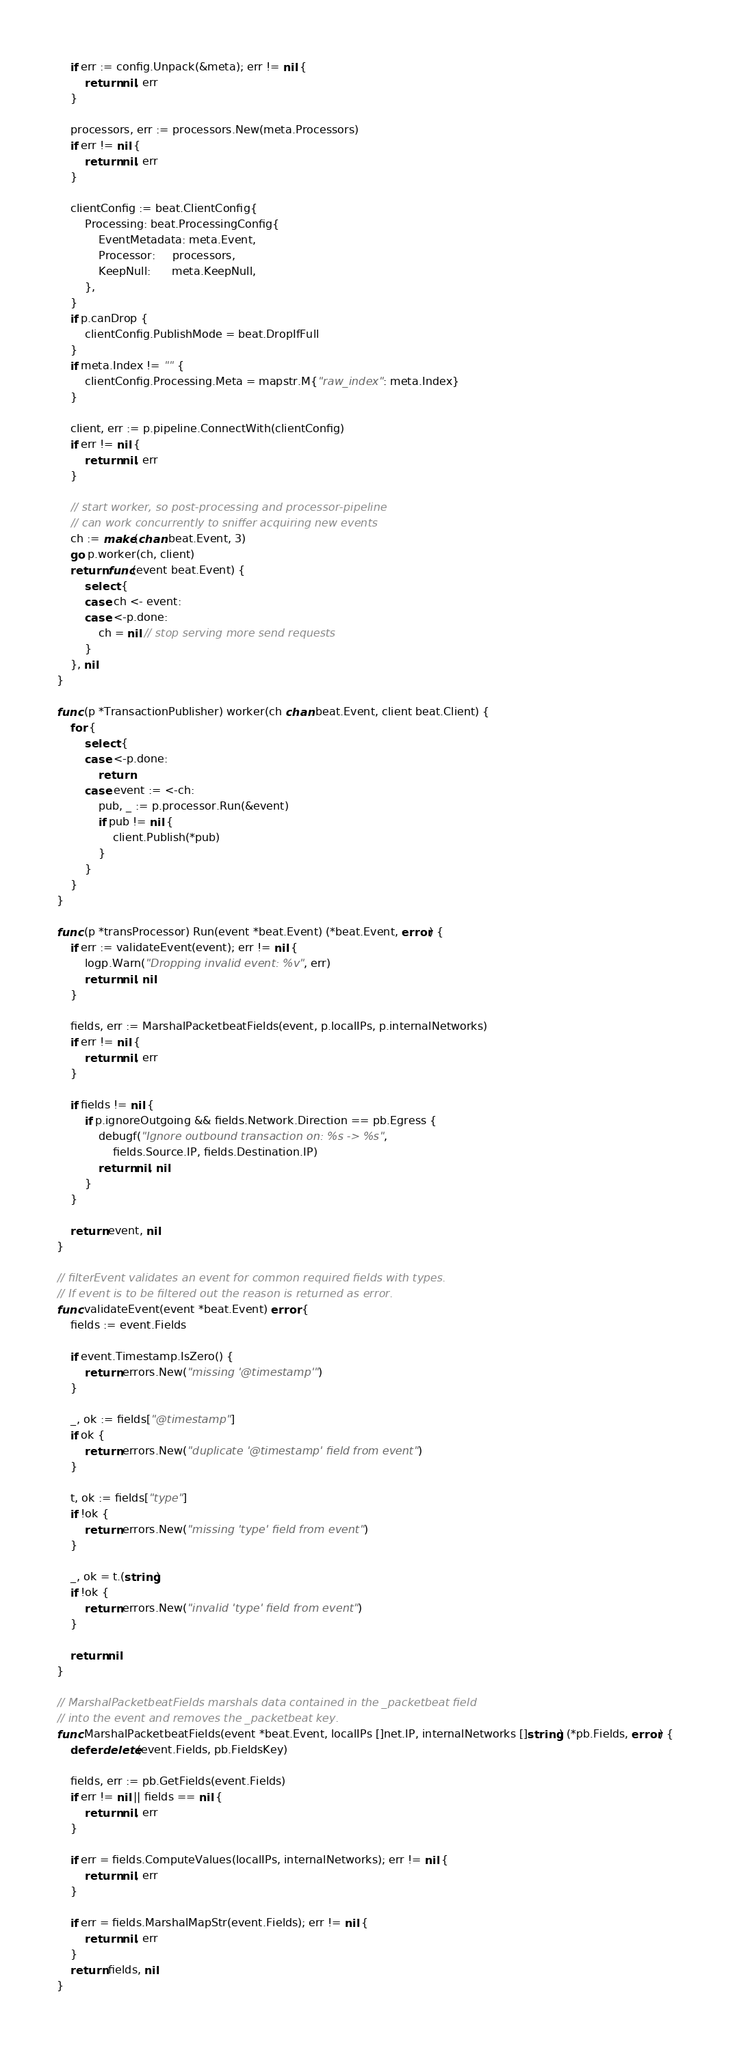Convert code to text. <code><loc_0><loc_0><loc_500><loc_500><_Go_>	if err := config.Unpack(&meta); err != nil {
		return nil, err
	}

	processors, err := processors.New(meta.Processors)
	if err != nil {
		return nil, err
	}

	clientConfig := beat.ClientConfig{
		Processing: beat.ProcessingConfig{
			EventMetadata: meta.Event,
			Processor:     processors,
			KeepNull:      meta.KeepNull,
		},
	}
	if p.canDrop {
		clientConfig.PublishMode = beat.DropIfFull
	}
	if meta.Index != "" {
		clientConfig.Processing.Meta = mapstr.M{"raw_index": meta.Index}
	}

	client, err := p.pipeline.ConnectWith(clientConfig)
	if err != nil {
		return nil, err
	}

	// start worker, so post-processing and processor-pipeline
	// can work concurrently to sniffer acquiring new events
	ch := make(chan beat.Event, 3)
	go p.worker(ch, client)
	return func(event beat.Event) {
		select {
		case ch <- event:
		case <-p.done:
			ch = nil // stop serving more send requests
		}
	}, nil
}

func (p *TransactionPublisher) worker(ch chan beat.Event, client beat.Client) {
	for {
		select {
		case <-p.done:
			return
		case event := <-ch:
			pub, _ := p.processor.Run(&event)
			if pub != nil {
				client.Publish(*pub)
			}
		}
	}
}

func (p *transProcessor) Run(event *beat.Event) (*beat.Event, error) {
	if err := validateEvent(event); err != nil {
		logp.Warn("Dropping invalid event: %v", err)
		return nil, nil
	}

	fields, err := MarshalPacketbeatFields(event, p.localIPs, p.internalNetworks)
	if err != nil {
		return nil, err
	}

	if fields != nil {
		if p.ignoreOutgoing && fields.Network.Direction == pb.Egress {
			debugf("Ignore outbound transaction on: %s -> %s",
				fields.Source.IP, fields.Destination.IP)
			return nil, nil
		}
	}

	return event, nil
}

// filterEvent validates an event for common required fields with types.
// If event is to be filtered out the reason is returned as error.
func validateEvent(event *beat.Event) error {
	fields := event.Fields

	if event.Timestamp.IsZero() {
		return errors.New("missing '@timestamp'")
	}

	_, ok := fields["@timestamp"]
	if ok {
		return errors.New("duplicate '@timestamp' field from event")
	}

	t, ok := fields["type"]
	if !ok {
		return errors.New("missing 'type' field from event")
	}

	_, ok = t.(string)
	if !ok {
		return errors.New("invalid 'type' field from event")
	}

	return nil
}

// MarshalPacketbeatFields marshals data contained in the _packetbeat field
// into the event and removes the _packetbeat key.
func MarshalPacketbeatFields(event *beat.Event, localIPs []net.IP, internalNetworks []string) (*pb.Fields, error) {
	defer delete(event.Fields, pb.FieldsKey)

	fields, err := pb.GetFields(event.Fields)
	if err != nil || fields == nil {
		return nil, err
	}

	if err = fields.ComputeValues(localIPs, internalNetworks); err != nil {
		return nil, err
	}

	if err = fields.MarshalMapStr(event.Fields); err != nil {
		return nil, err
	}
	return fields, nil
}
</code> 